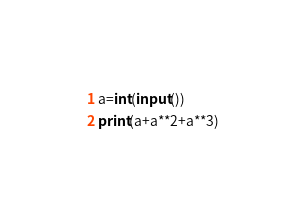Convert code to text. <code><loc_0><loc_0><loc_500><loc_500><_Python_>a=int(input())
print(a+a**2+a**3)</code> 